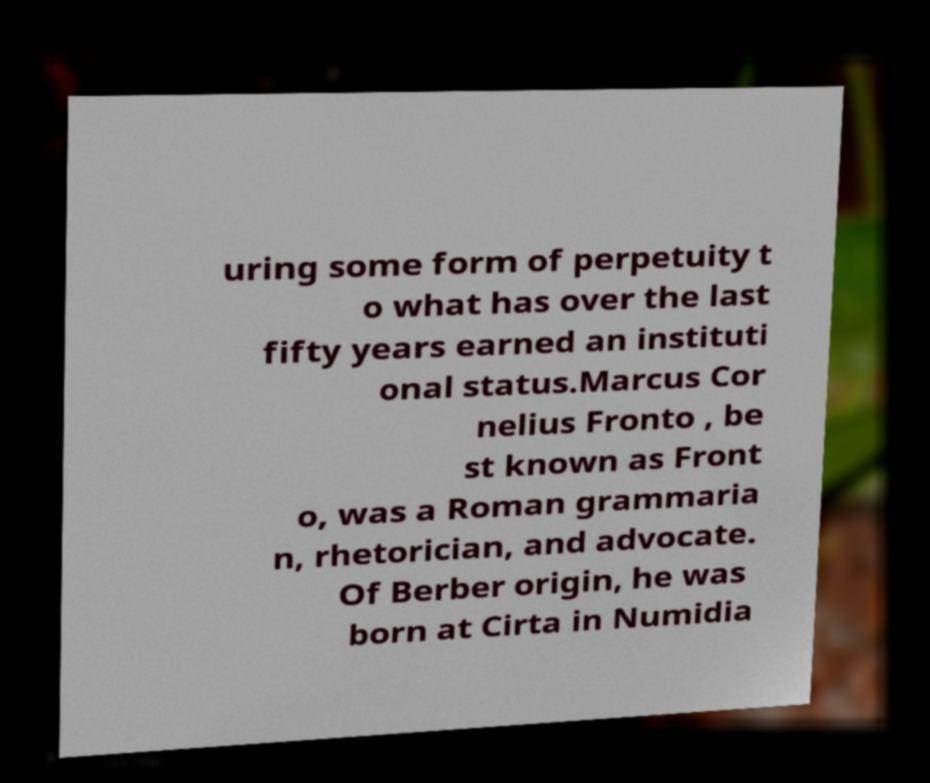I need the written content from this picture converted into text. Can you do that? uring some form of perpetuity t o what has over the last fifty years earned an instituti onal status.Marcus Cor nelius Fronto , be st known as Front o, was a Roman grammaria n, rhetorician, and advocate. Of Berber origin, he was born at Cirta in Numidia 